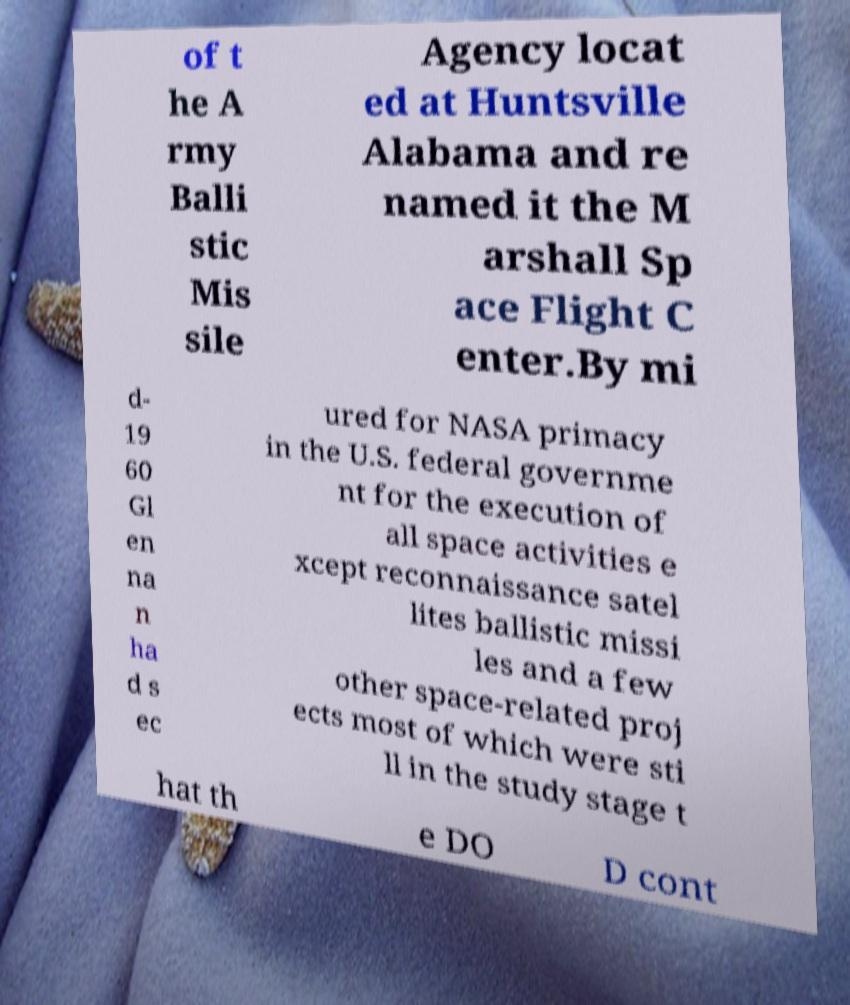Can you read and provide the text displayed in the image?This photo seems to have some interesting text. Can you extract and type it out for me? of t he A rmy Balli stic Mis sile Agency locat ed at Huntsville Alabama and re named it the M arshall Sp ace Flight C enter.By mi d- 19 60 Gl en na n ha d s ec ured for NASA primacy in the U.S. federal governme nt for the execution of all space activities e xcept reconnaissance satel lites ballistic missi les and a few other space-related proj ects most of which were sti ll in the study stage t hat th e DO D cont 